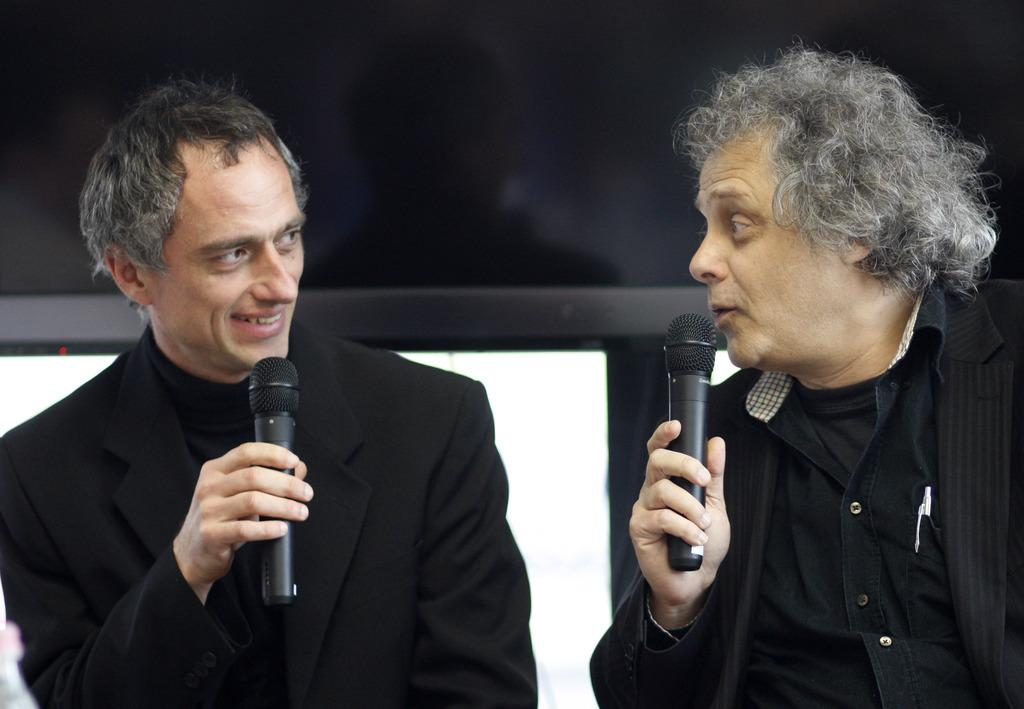How many people are in the image? There are two persons in the image. What are the two persons holding in their hands? The two persons are holding microphones. What type of wrench is being used by one of the persons in the image? There is no wrench present in the image; both persons are holding microphones. 